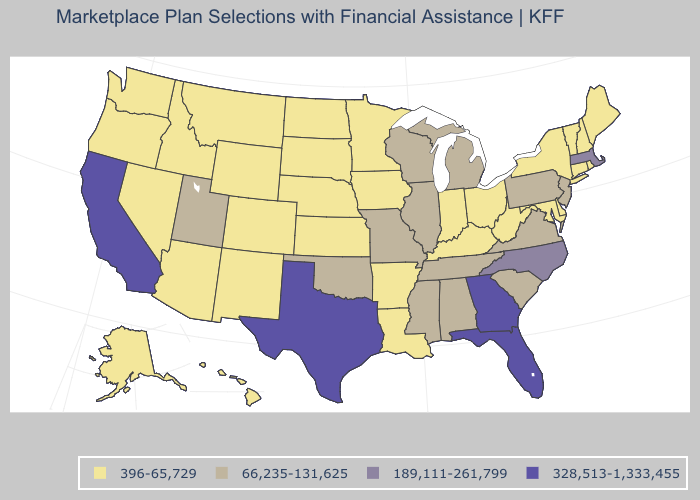What is the lowest value in the West?
Quick response, please. 396-65,729. Name the states that have a value in the range 396-65,729?
Answer briefly. Alaska, Arizona, Arkansas, Colorado, Connecticut, Delaware, Hawaii, Idaho, Indiana, Iowa, Kansas, Kentucky, Louisiana, Maine, Maryland, Minnesota, Montana, Nebraska, Nevada, New Hampshire, New Mexico, New York, North Dakota, Ohio, Oregon, Rhode Island, South Dakota, Vermont, Washington, West Virginia, Wyoming. Among the states that border Delaware , does Pennsylvania have the highest value?
Give a very brief answer. Yes. Name the states that have a value in the range 189,111-261,799?
Give a very brief answer. Massachusetts, North Carolina. What is the value of Michigan?
Give a very brief answer. 66,235-131,625. Does Nevada have the same value as Arizona?
Quick response, please. Yes. What is the highest value in the USA?
Be succinct. 328,513-1,333,455. Does Kansas have the highest value in the MidWest?
Quick response, please. No. What is the value of Montana?
Keep it brief. 396-65,729. Among the states that border New Hampshire , does Massachusetts have the lowest value?
Write a very short answer. No. Does the first symbol in the legend represent the smallest category?
Quick response, please. Yes. Among the states that border Kansas , does Oklahoma have the lowest value?
Be succinct. No. Which states have the highest value in the USA?
Write a very short answer. California, Florida, Georgia, Texas. What is the value of Washington?
Answer briefly. 396-65,729. 